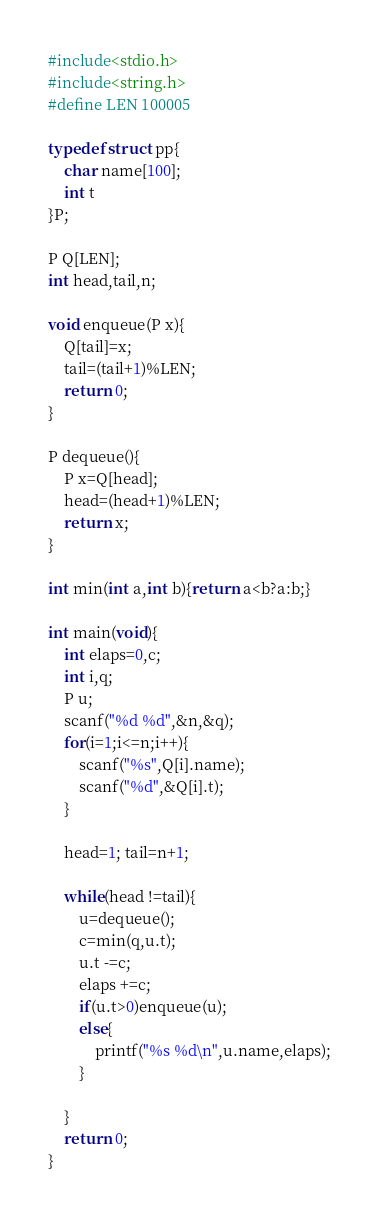<code> <loc_0><loc_0><loc_500><loc_500><_C_>#include<stdio.h>
#include<string.h>
#define LEN 100005

typedef struct pp{
	char name[100];
	int t
}P;

P Q[LEN];
int head,tail,n;

void enqueue(P x){
	Q[tail]=x;
	tail=(tail+1)%LEN;
	return 0;
}

P dequeue(){
	P x=Q[head];
	head=(head+1)%LEN;
	return x;
}

int min(int a,int b){return a<b?a:b;}

int main(void){
	int elaps=0,c;
	int i,q;
	P u;
	scanf("%d %d",&n,&q);
	for(i=1;i<=n;i++){
		scanf("%s",Q[i].name);
		scanf("%d",&Q[i].t);
	}
	
	head=1; tail=n+1;
	
	while(head !=tail){
		u=dequeue();
		c=min(q,u.t);
		u.t -=c;
		elaps +=c;
		if(u.t>0)enqueue(u);
		else{
			printf("%s %d\n",u.name,elaps);
		}
	
	}
	return 0;
}
</code> 